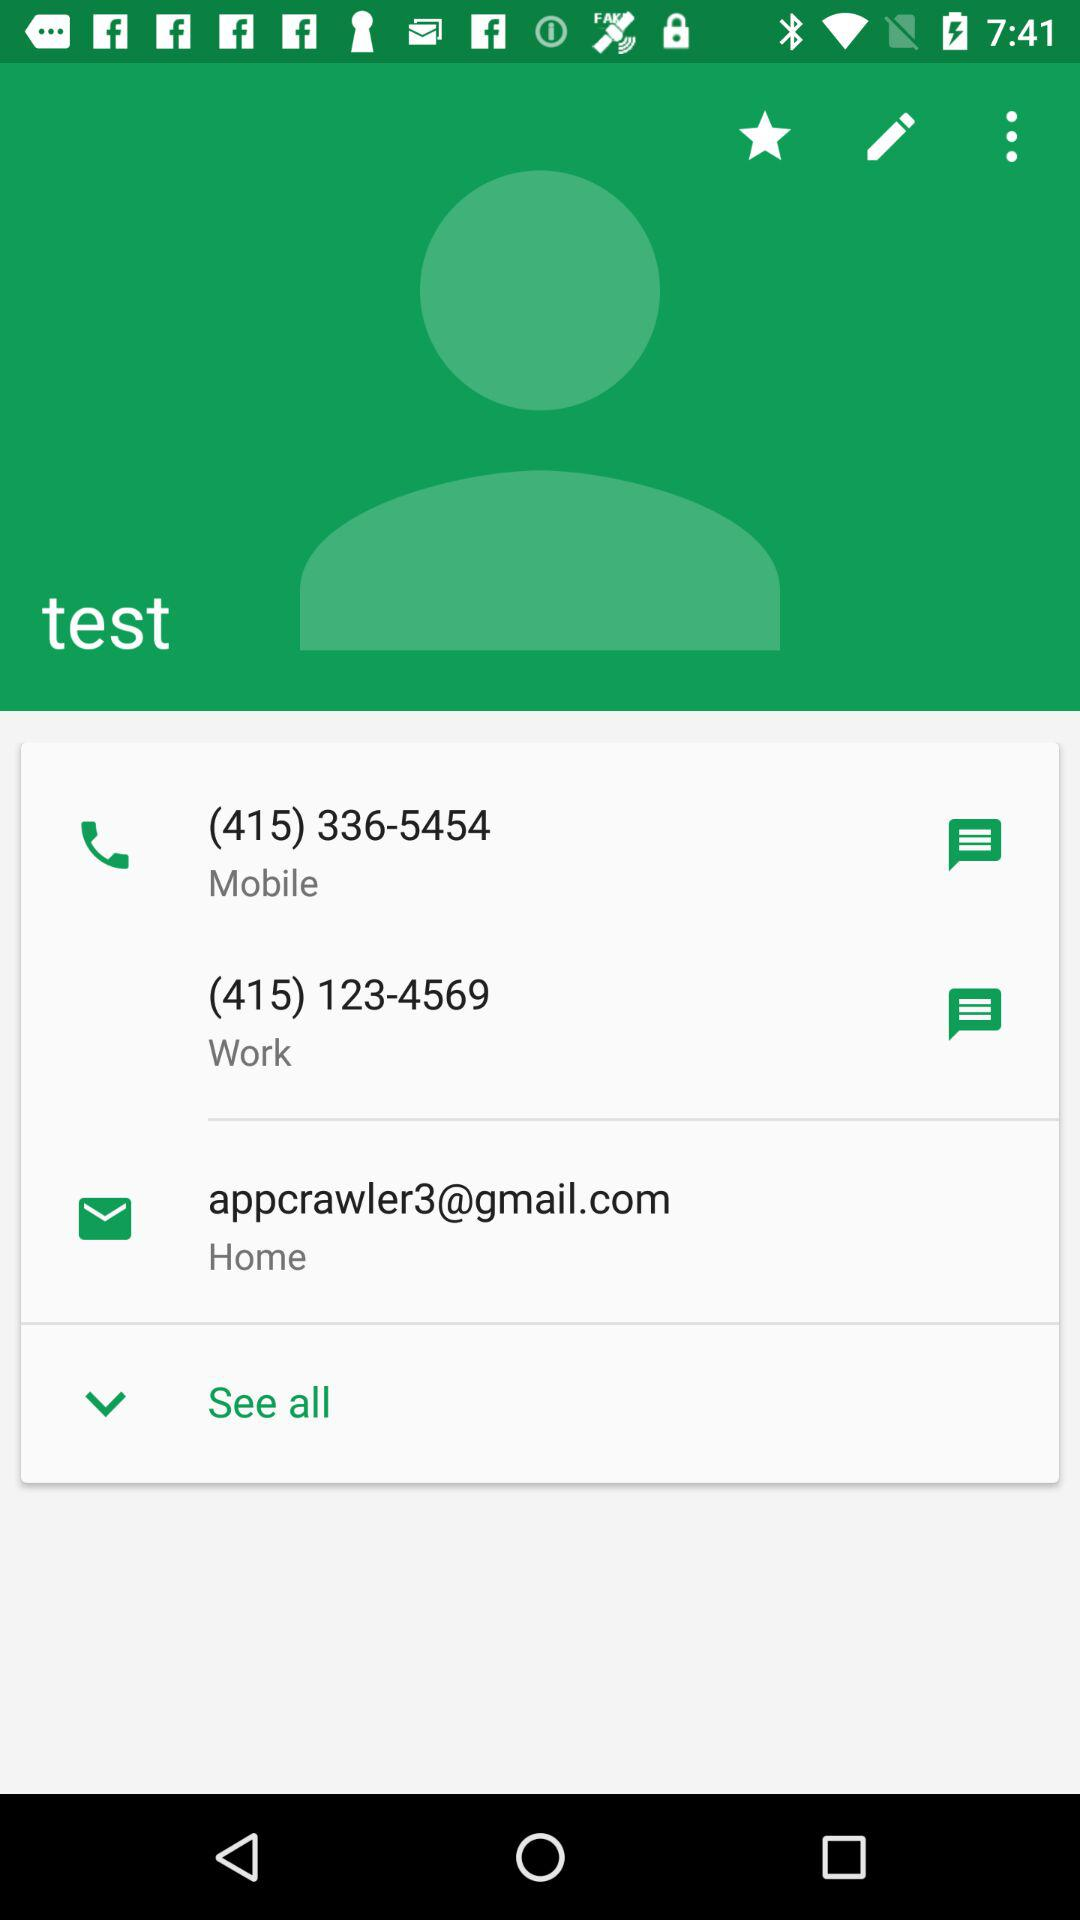What is the contact number for "test" at "Work"? The contact number for "test" at "Work" is (415) 123-4569. 